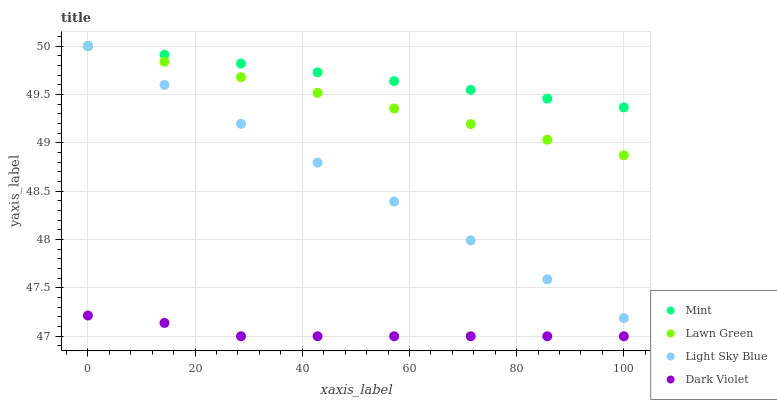Does Dark Violet have the minimum area under the curve?
Answer yes or no. Yes. Does Mint have the maximum area under the curve?
Answer yes or no. Yes. Does Light Sky Blue have the minimum area under the curve?
Answer yes or no. No. Does Light Sky Blue have the maximum area under the curve?
Answer yes or no. No. Is Mint the smoothest?
Answer yes or no. Yes. Is Dark Violet the roughest?
Answer yes or no. Yes. Is Light Sky Blue the smoothest?
Answer yes or no. No. Is Light Sky Blue the roughest?
Answer yes or no. No. Does Dark Violet have the lowest value?
Answer yes or no. Yes. Does Light Sky Blue have the lowest value?
Answer yes or no. No. Does Mint have the highest value?
Answer yes or no. Yes. Does Dark Violet have the highest value?
Answer yes or no. No. Is Dark Violet less than Mint?
Answer yes or no. Yes. Is Lawn Green greater than Dark Violet?
Answer yes or no. Yes. Does Lawn Green intersect Mint?
Answer yes or no. Yes. Is Lawn Green less than Mint?
Answer yes or no. No. Is Lawn Green greater than Mint?
Answer yes or no. No. Does Dark Violet intersect Mint?
Answer yes or no. No. 